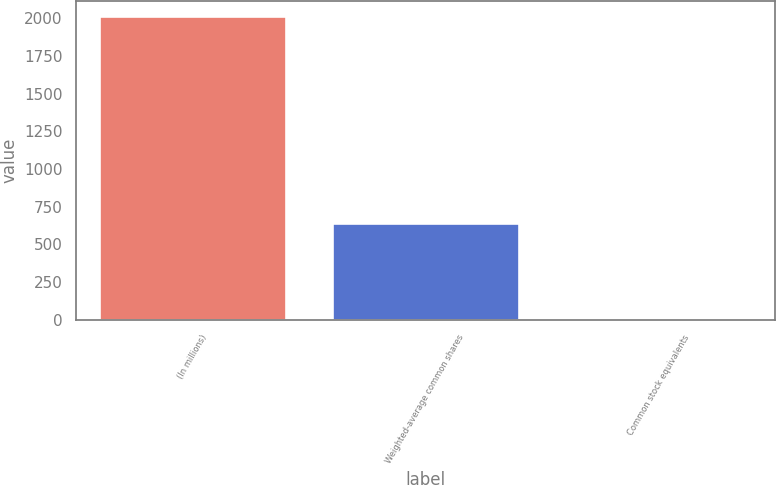Convert chart. <chart><loc_0><loc_0><loc_500><loc_500><bar_chart><fcel>(In millions)<fcel>Weighted-average common shares<fcel>Common stock equivalents<nl><fcel>2016<fcel>641.48<fcel>7.2<nl></chart> 